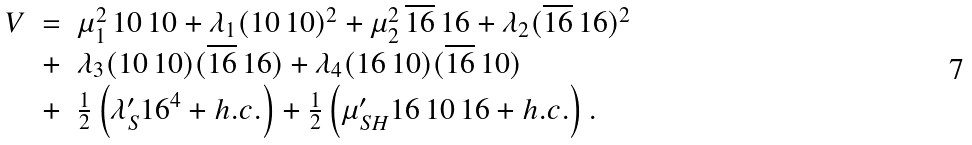<formula> <loc_0><loc_0><loc_500><loc_500>\begin{array} { r c l } V & = & \mu _ { 1 } ^ { 2 } \, { 1 0 } \, { 1 0 } + \lambda _ { 1 } ( { 1 0 } \, { 1 0 } ) ^ { 2 } + \mu _ { 2 } ^ { 2 } \, \overline { 1 6 } \, { 1 6 } + \lambda _ { 2 } ( \overline { 1 6 } \, { 1 6 } ) ^ { 2 } \\ & + & \lambda _ { 3 } ( { 1 0 } \, { 1 0 } ) ( \overline { 1 6 } \, { 1 6 } ) + \lambda _ { 4 } ( { 1 6 \, } { 1 0 } ) ( \overline { 1 6 } \, { 1 0 } ) \\ & + & \frac { 1 } { 2 } \left ( \lambda ^ { \prime } _ { S } { 1 6 } ^ { 4 } + h . c . \right ) + \frac { 1 } { 2 } \left ( \mu ^ { \prime } _ { S H } { 1 6 \, } { 1 0 \, } { 1 6 } + h . c . \right ) . \end{array}</formula> 